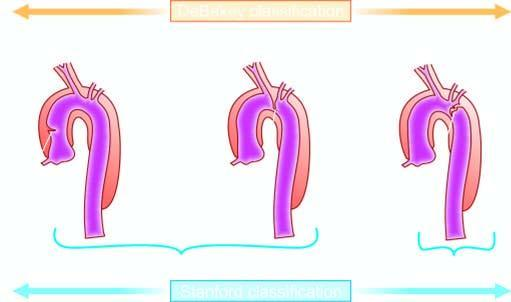does stanford type a involving ascending aorta include includes debakey 's type i and ii?
Answer the question using a single word or phrase. Yes 